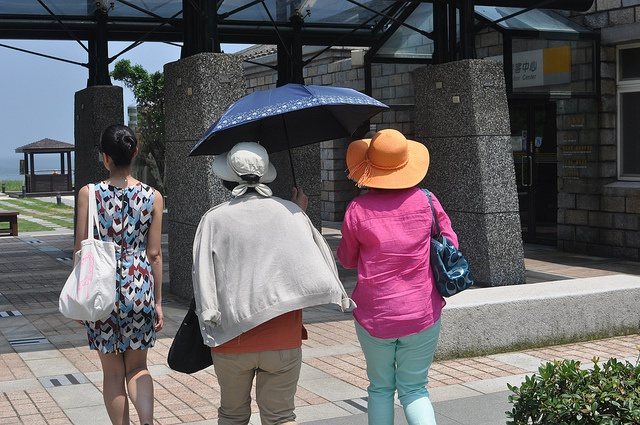Describe the objects in this image and their specific colors. I can see people in blue, lightgray, gray, darkgray, and maroon tones, people in blue, violet, purple, and teal tones, people in blue, gray, black, and darkgray tones, umbrella in blue, black, gray, and darkgray tones, and handbag in blue, lightgray, darkgray, gray, and pink tones in this image. 